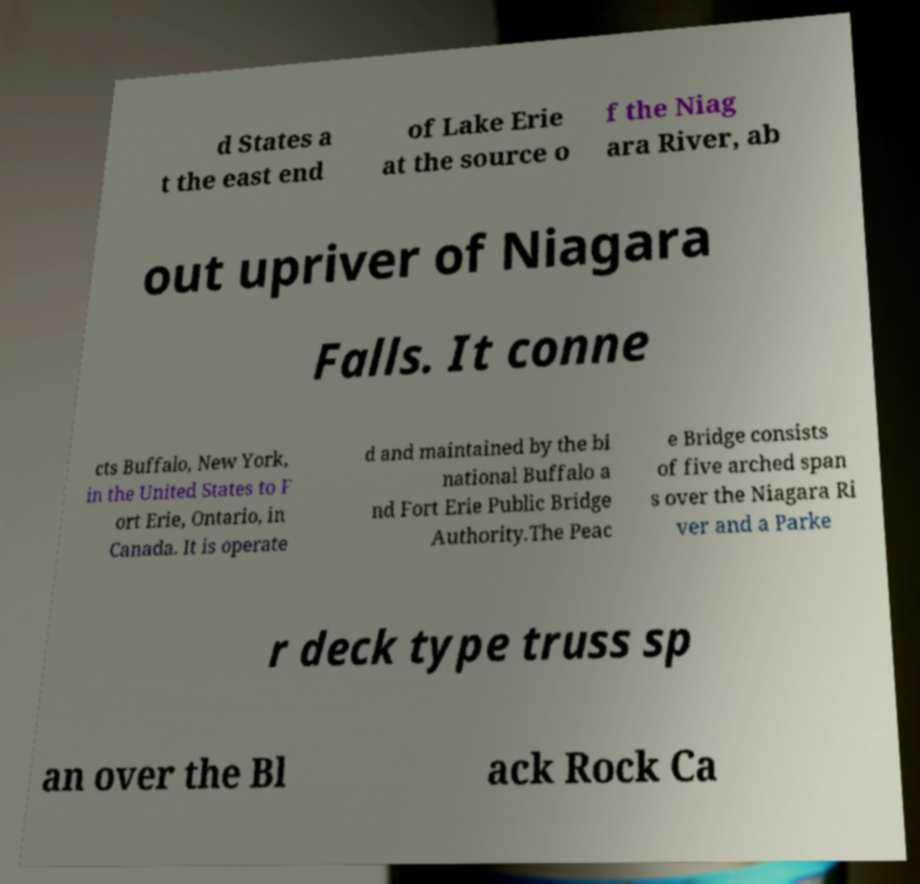Could you assist in decoding the text presented in this image and type it out clearly? d States a t the east end of Lake Erie at the source o f the Niag ara River, ab out upriver of Niagara Falls. It conne cts Buffalo, New York, in the United States to F ort Erie, Ontario, in Canada. It is operate d and maintained by the bi national Buffalo a nd Fort Erie Public Bridge Authority.The Peac e Bridge consists of five arched span s over the Niagara Ri ver and a Parke r deck type truss sp an over the Bl ack Rock Ca 